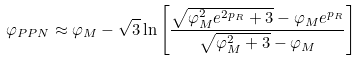Convert formula to latex. <formula><loc_0><loc_0><loc_500><loc_500>\varphi _ { P P N } \approx \varphi _ { M } - \sqrt { 3 } \ln \left [ \frac { \sqrt { \varphi ^ { 2 } _ { M } e ^ { 2 p _ { R } } + 3 } - \varphi _ { M } e ^ { p _ { R } } } { \sqrt { \varphi ^ { 2 } _ { M } + 3 } - \varphi _ { M } } \right ]</formula> 